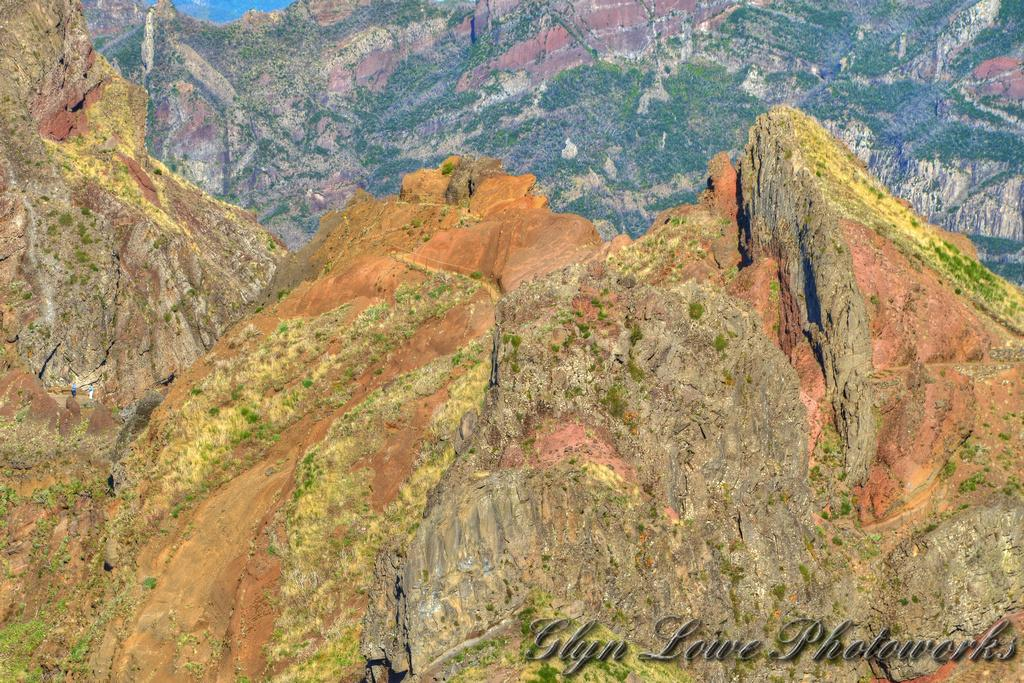What type of landscape is depicted in the image? The image features a mountainous landscape. Can you describe the characteristics of the mountains in the image? The mountains have different heights in the image. What type of yard can be seen in the image? There is no yard present in the image; it features a mountainous landscape. What month is it in the image? The image does not provide information about the month or time of year. 